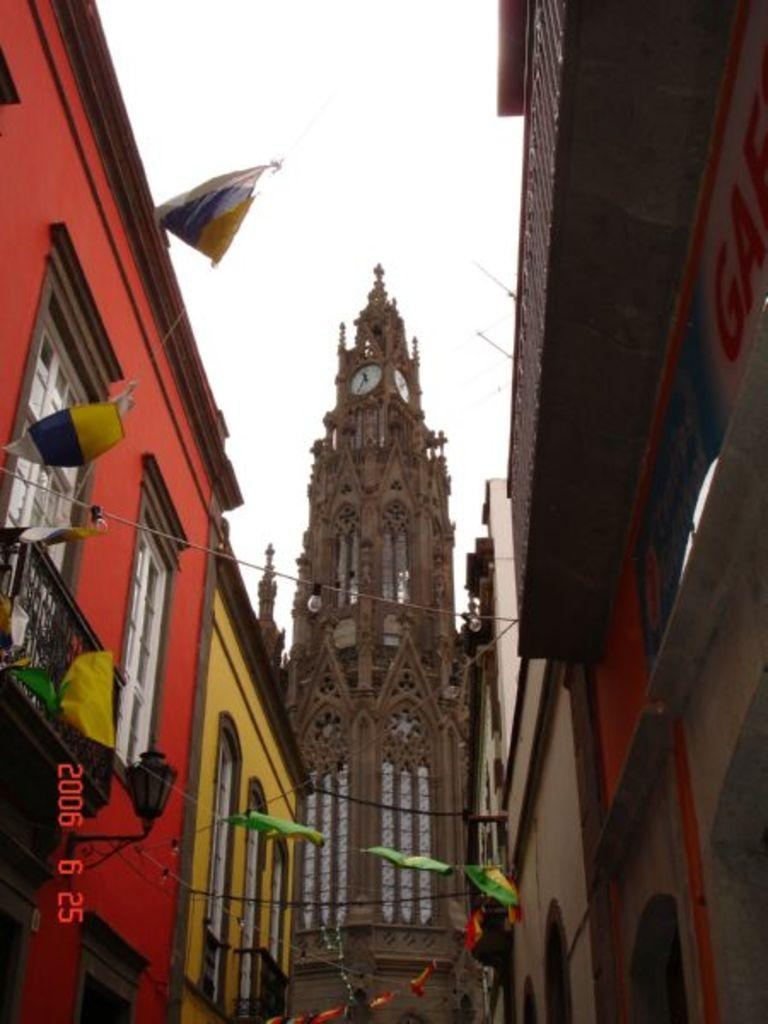What is the main structure in the center of the image? There is a tower in the center of the image. What other structures can be seen in the image? There are buildings in the image. What additional elements are visible in the image? There are flags visible in the image. What can be seen in the background of the image? The sky is visible in the background of the image. What type of relation does the crow have with the tower in the image? There is no crow present in the image, so it is not possible to determine any relation between a crow and the tower. 